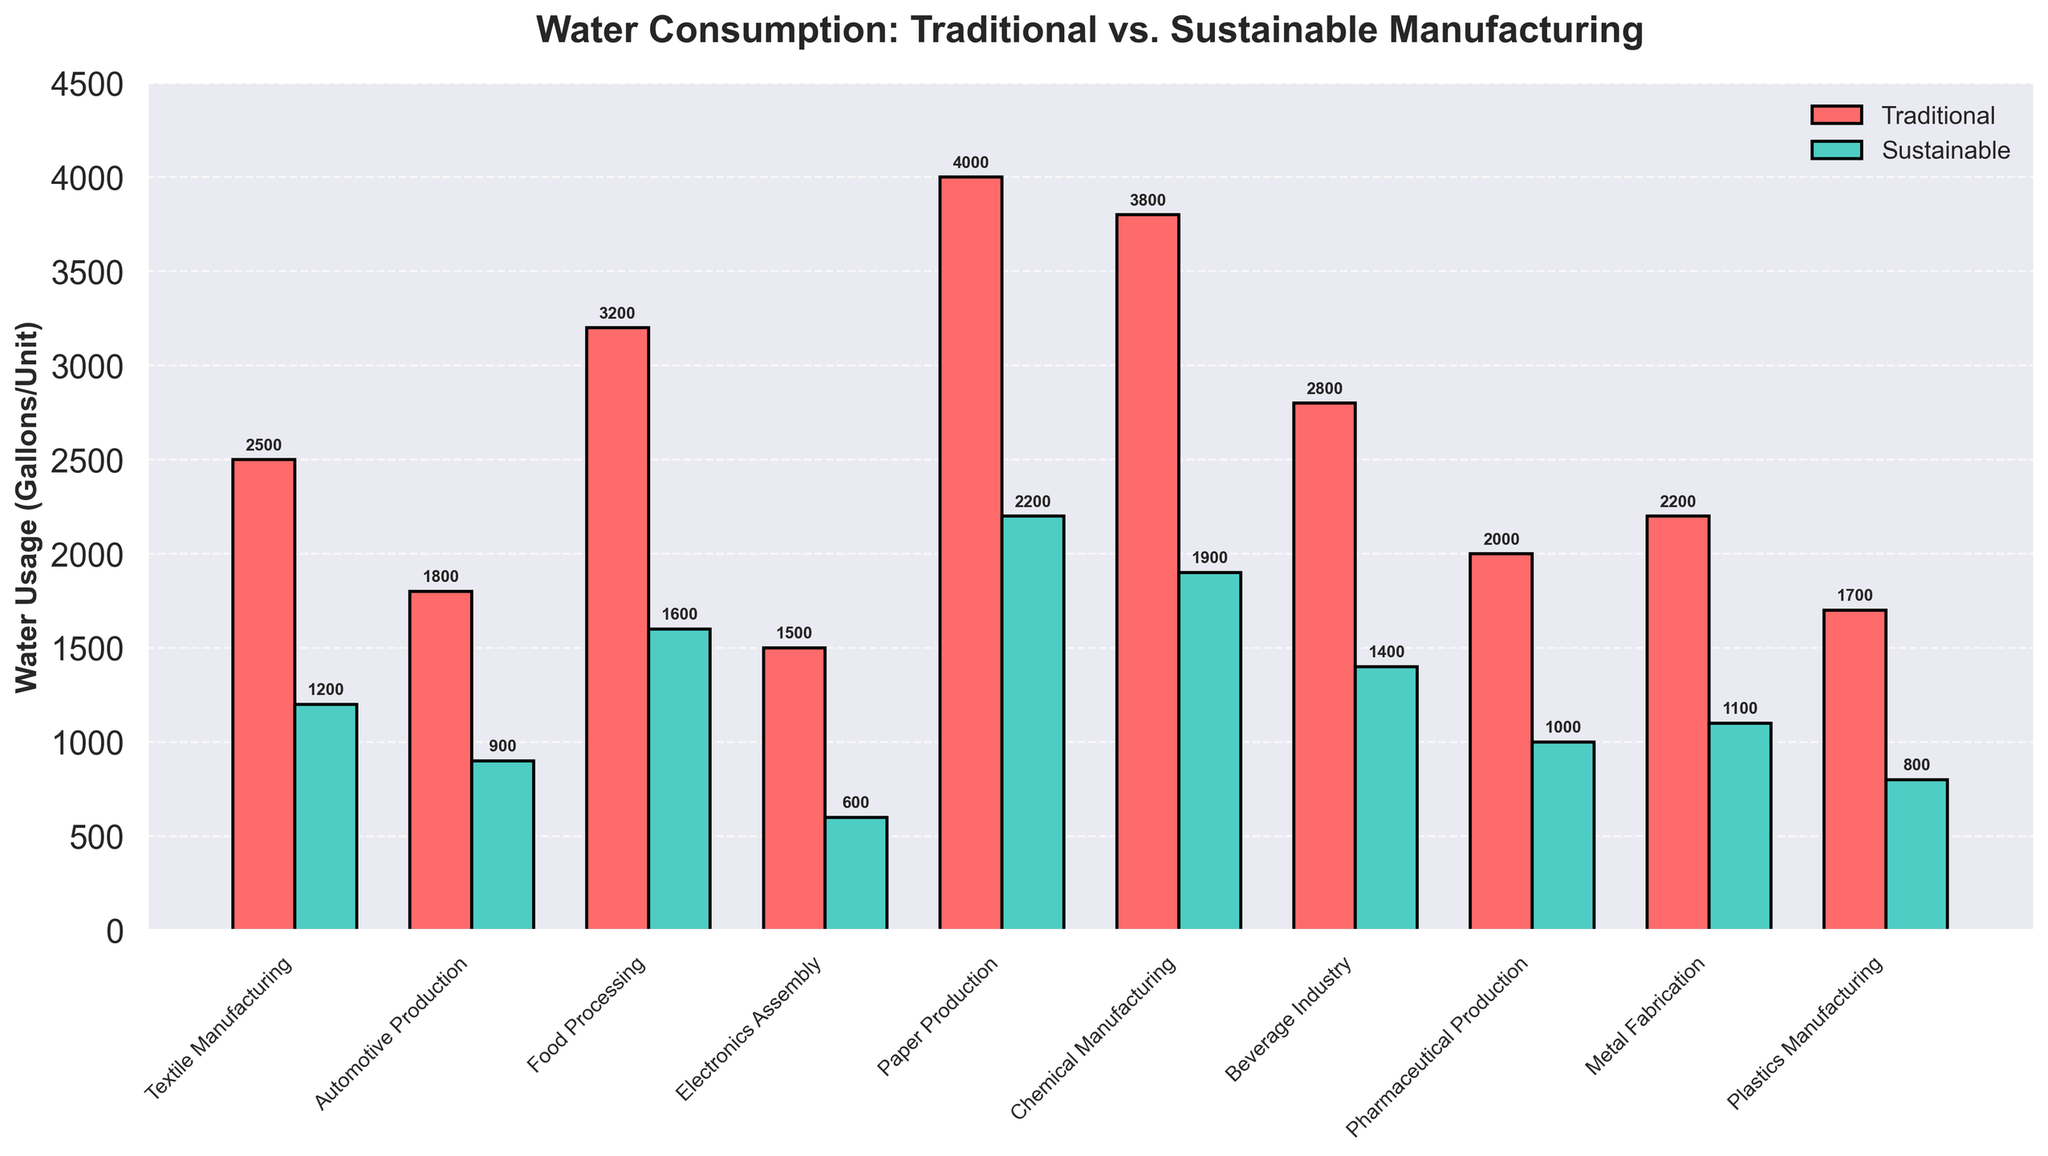Which industry has the highest traditional water usage? First, identify the highest bar in the traditional (red) category. The highest bar corresponds to Paper Production with 4000 gallons/unit.
Answer: Paper Production How much water is saved per unit in the Food Processing industry by using sustainable methods? The traditional water usage is 3200 gallons/unit, and the sustainable water usage is 1600 gallons/unit. The difference is 3200 - 1600 = 1600 gallons/unit.
Answer: 1600 gallons/unit What is the average sustainable water usage across all industries? Sum the sustainable water usage values and then divide by the number of industries. The sum is (1200 + 900 + 1600 + 600 + 2200 + 1900 + 1400 + 1000 + 1100 + 800) = 13700. The number of industries is 10. Therefore, the average is 13700 / 10 = 1370 gallons/unit.
Answer: 1370 gallons/unit Which industry shows the largest reduction in water usage when switching from traditional to sustainable methods? Calculate the difference in water usage for each industry by subtracting the sustainable usage from the traditional usage. The largest reduction is observed in Food Processing with a reduction of 3200 - 1600 = 1600 gallons/unit.
Answer: Food Processing How does the water usage of the Automotive Production industry compare to the Beverage Industry under both traditional and sustainable methods? For traditional methods, compare the bars: Automotive Production uses 1800 gallons/unit and Beverage Industry uses 2800 gallons/unit. For sustainable methods, compare the bars: Automotive Production uses 900 gallons/unit and Beverage Industry uses 1400 gallons/unit. Therefore, Automotive Production uses less water than the Beverage Industry in both methods.
Answer: Automotive Production uses less in both methods What is the total traditional water usage for all industries combined? Sum the traditional water usage for all industries: 2500 + 1800 + 3200 + 1500 + 4000 + 3800 + 2800 + 2000 + 2200 + 1700 = 25500 gallons/unit.
Answer: 25500 gallons/unit Which industry has the smallest difference between traditional and sustainable water usage? Calculate the difference for each industry and find the smallest one. The differences are: Textile (1300), Automotive (900), Food (1600), Electronics (900), Paper (1800), Chemical (1900), Beverage (1400), Pharma (1000), Metal (1100), Plastics (900). The smallest difference is in Automotive, Electronics, and Plastics each with 900 gallons/unit.
Answer: Automotive, Electronics, and Plastics Are there any industries where sustainable methods use more than half the water of traditional methods? Compare the sustainable water usage to half of the corresponding traditional water usage for each industry. The industry with sustainable usage greater than half of the traditional usage is Paper Production (2200 > 2000).
Answer: Paper Production 